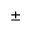Convert formula to latex. <formula><loc_0><loc_0><loc_500><loc_500>\pm</formula> 